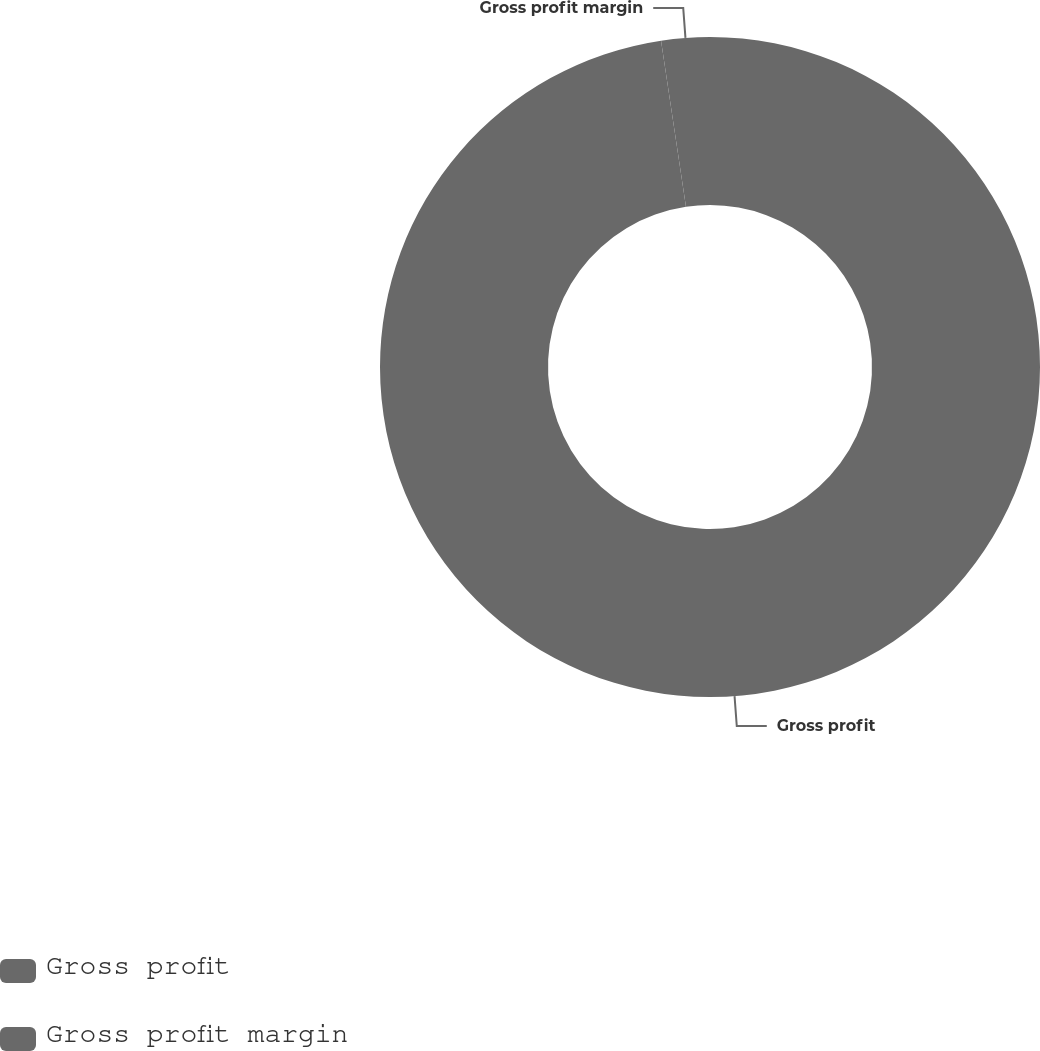Convert chart. <chart><loc_0><loc_0><loc_500><loc_500><pie_chart><fcel>Gross profit<fcel>Gross profit margin<nl><fcel>97.63%<fcel>2.37%<nl></chart> 